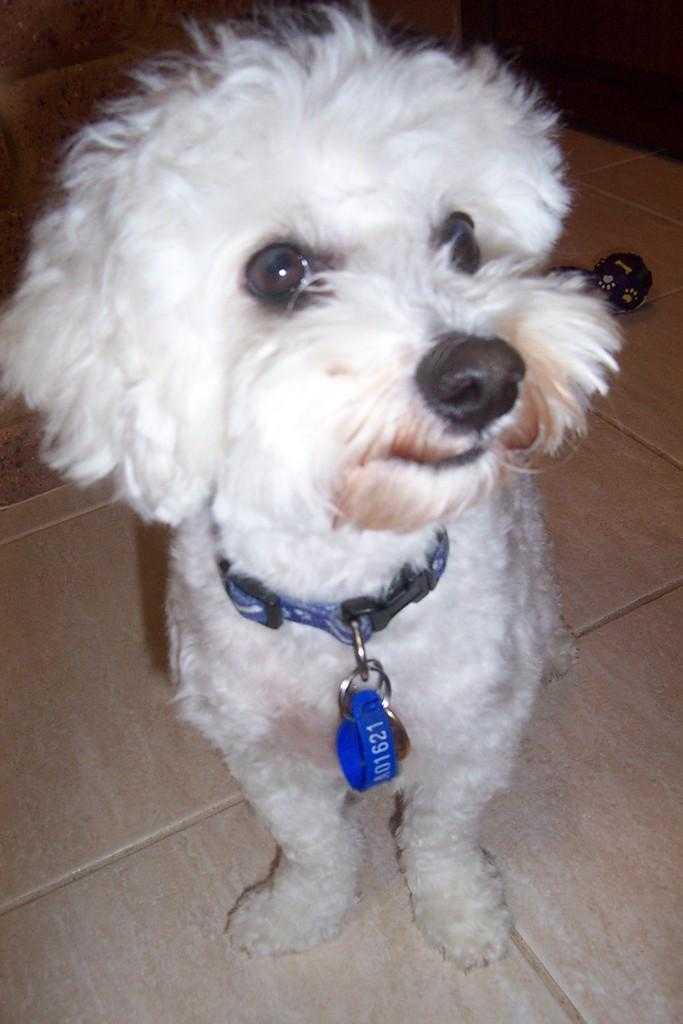What type of animal is present in the image? There is a dog in the image. What color is the dog? The dog is white in color. What other object can be seen in the image? There is a blue color belt in the image. What type of drug is the dog taking in the image? There is no indication in the image that the dog is taking any drug, and therefore no such activity can be observed. 